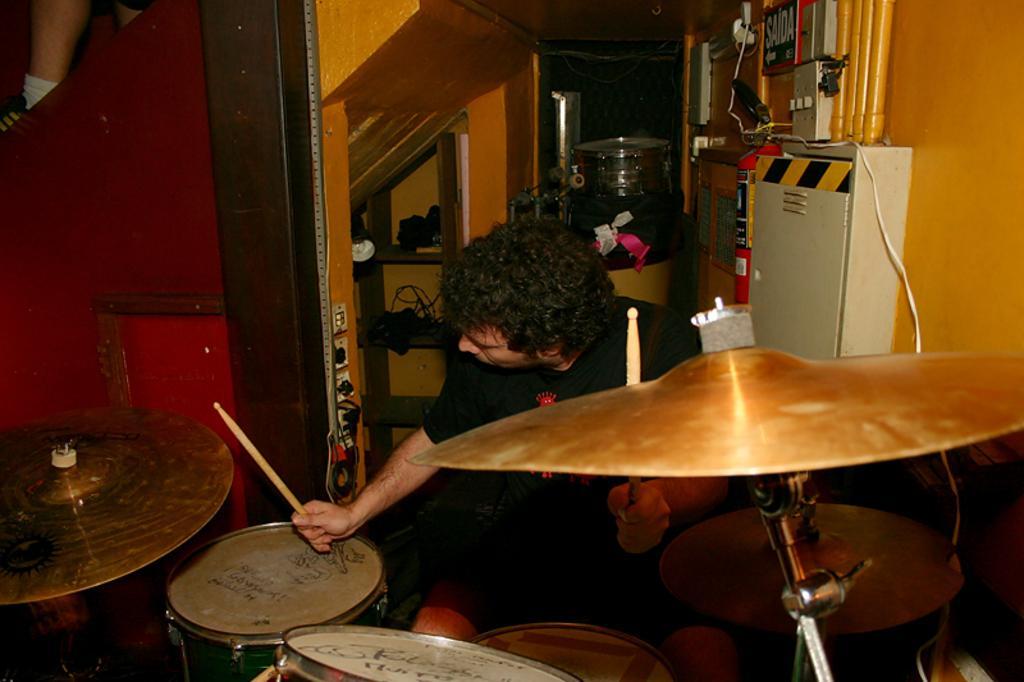Can you describe this image briefly? In this image I can see the person sitting in-front of the drum set. The person is wearing the black shirt and holding the stick. In the back I can see the rack and some objects can be seen. To the right there is a box and some boards. To the left there is a red color wall. 